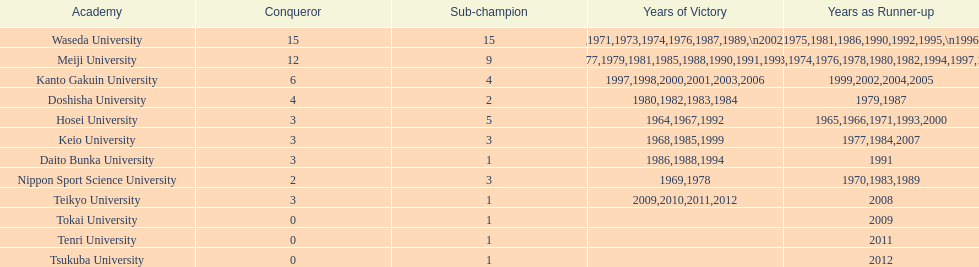What is the total number of championships held by nippon sport science university? 2. 